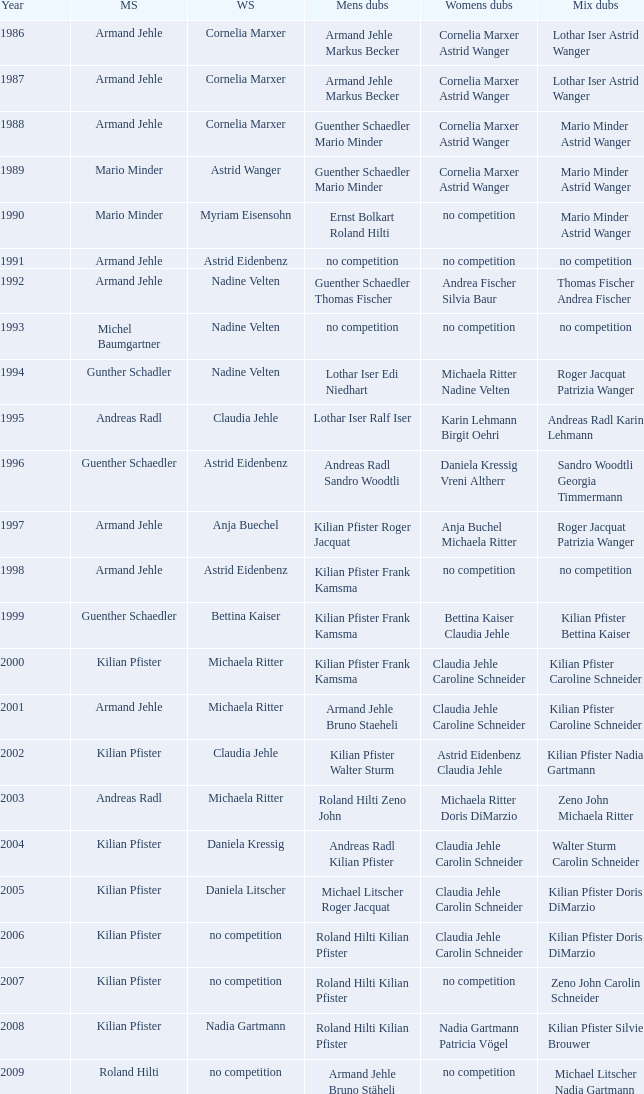What is the most current year where the women's doubles champions are astrid eidenbenz claudia jehle 2002.0. 